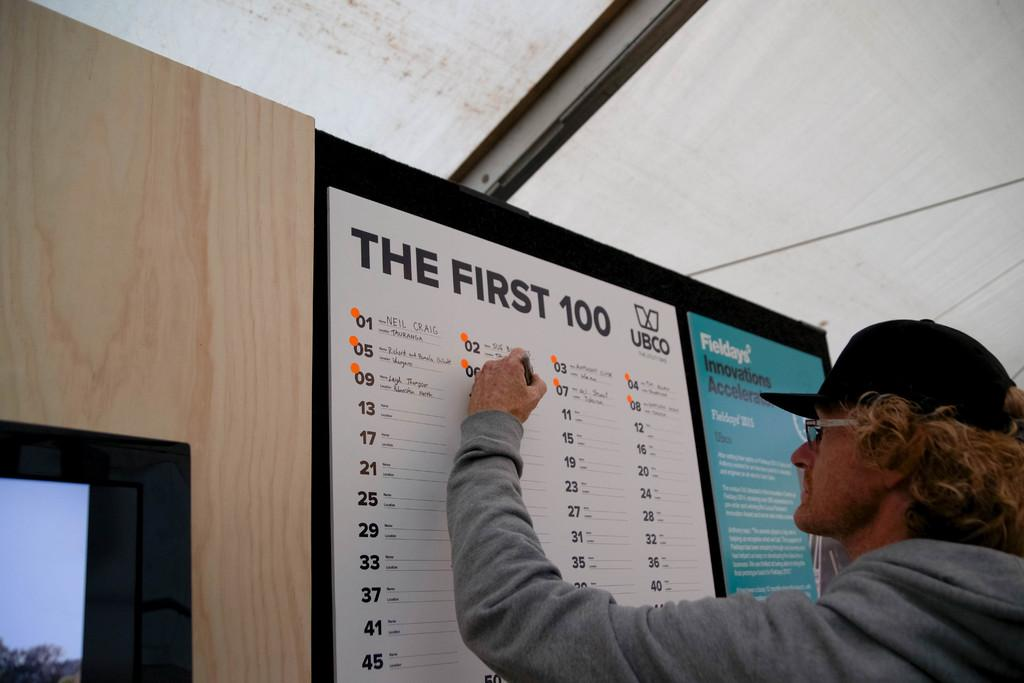<image>
Offer a succinct explanation of the picture presented. A man writing on a board with the title The First 100 on it. 